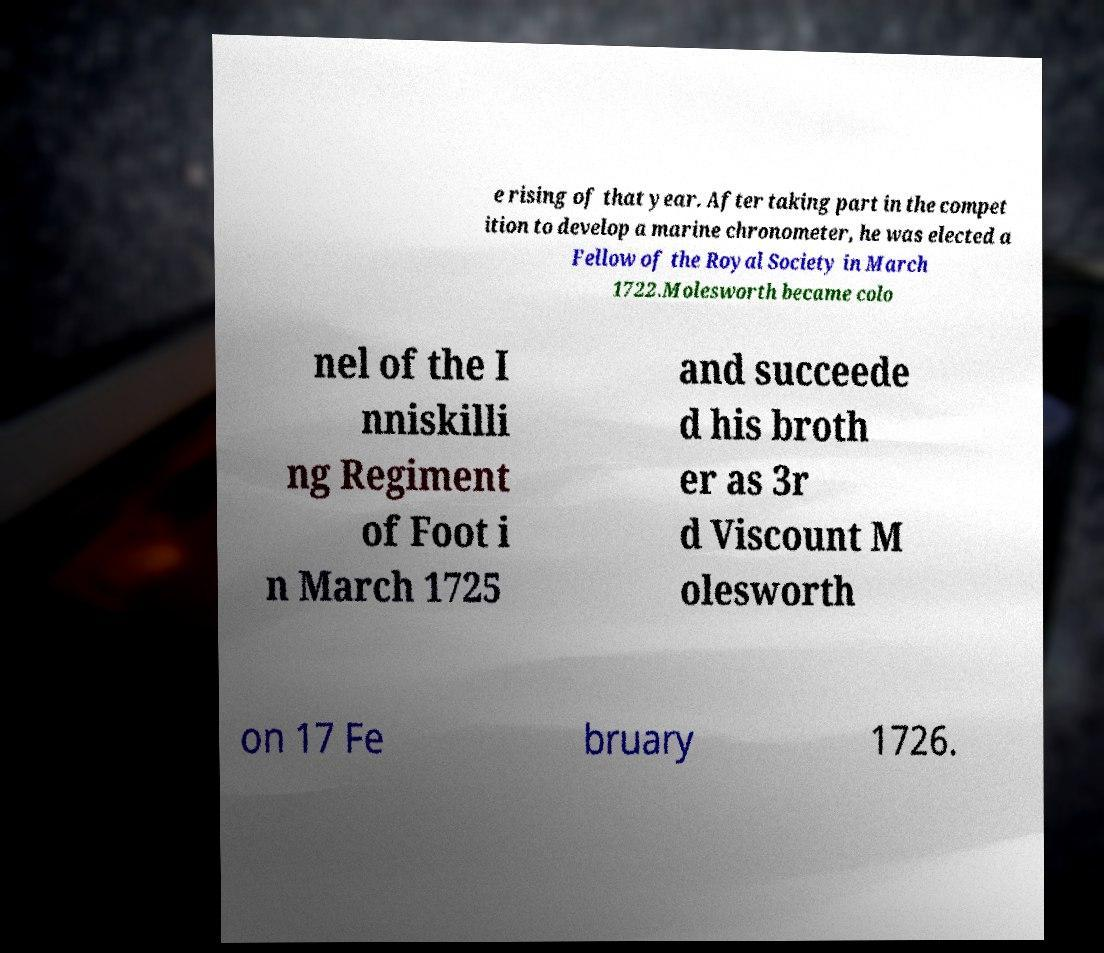Can you read and provide the text displayed in the image?This photo seems to have some interesting text. Can you extract and type it out for me? e rising of that year. After taking part in the compet ition to develop a marine chronometer, he was elected a Fellow of the Royal Society in March 1722.Molesworth became colo nel of the I nniskilli ng Regiment of Foot i n March 1725 and succeede d his broth er as 3r d Viscount M olesworth on 17 Fe bruary 1726. 